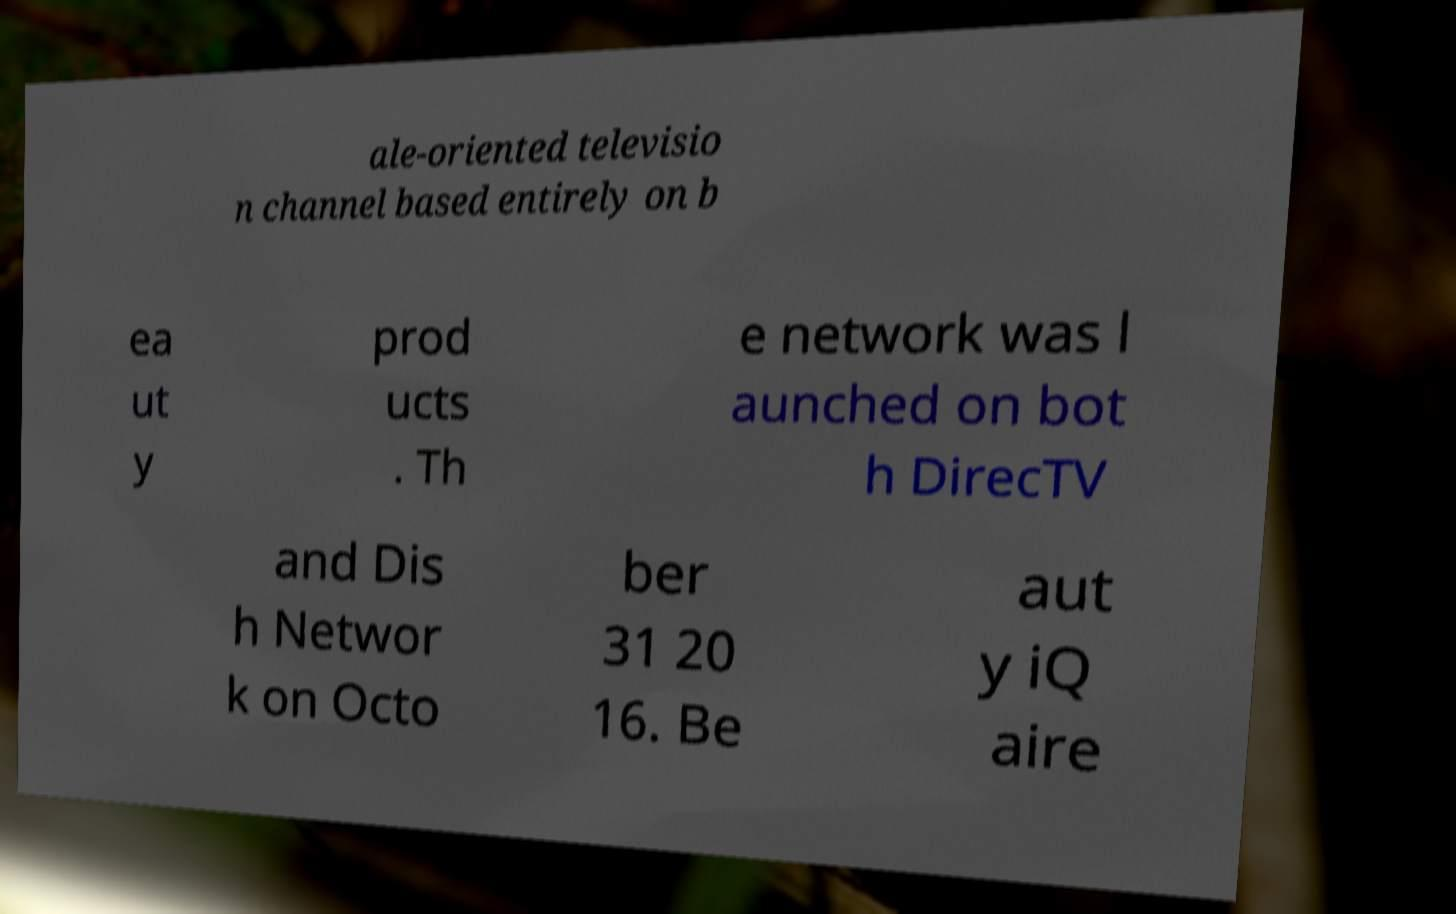Could you assist in decoding the text presented in this image and type it out clearly? ale-oriented televisio n channel based entirely on b ea ut y prod ucts . Th e network was l aunched on bot h DirecTV and Dis h Networ k on Octo ber 31 20 16. Be aut y iQ aire 